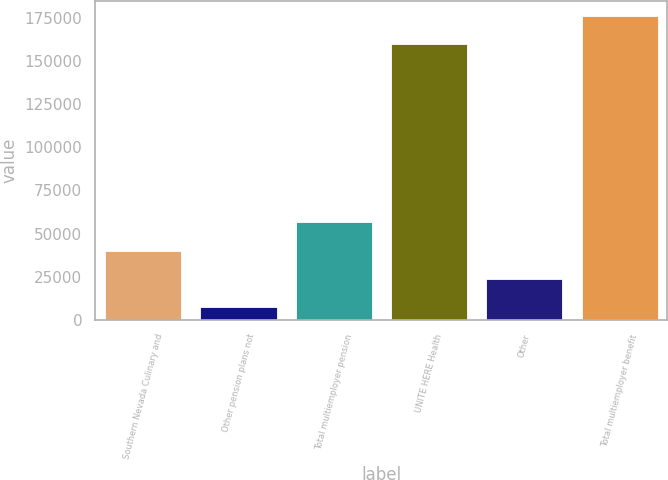Convert chart. <chart><loc_0><loc_0><loc_500><loc_500><bar_chart><fcel>Southern Nevada Culinary and<fcel>Other pension plans not<fcel>Total multiemployer pension<fcel>UNITE HERE Health<fcel>Other<fcel>Total multiemployer benefit<nl><fcel>40174.4<fcel>7485<fcel>56519.1<fcel>159757<fcel>23829.7<fcel>176102<nl></chart> 